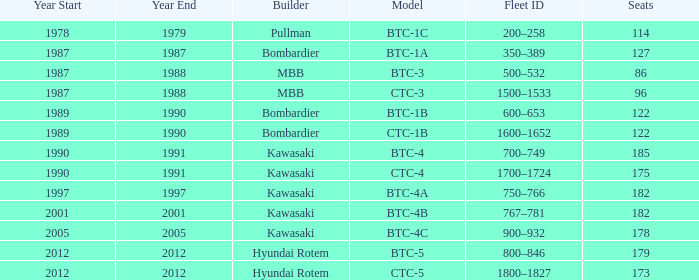For the train built in 2012 with less than 179 seats, what is the Fleet ID? 1800–1827. 